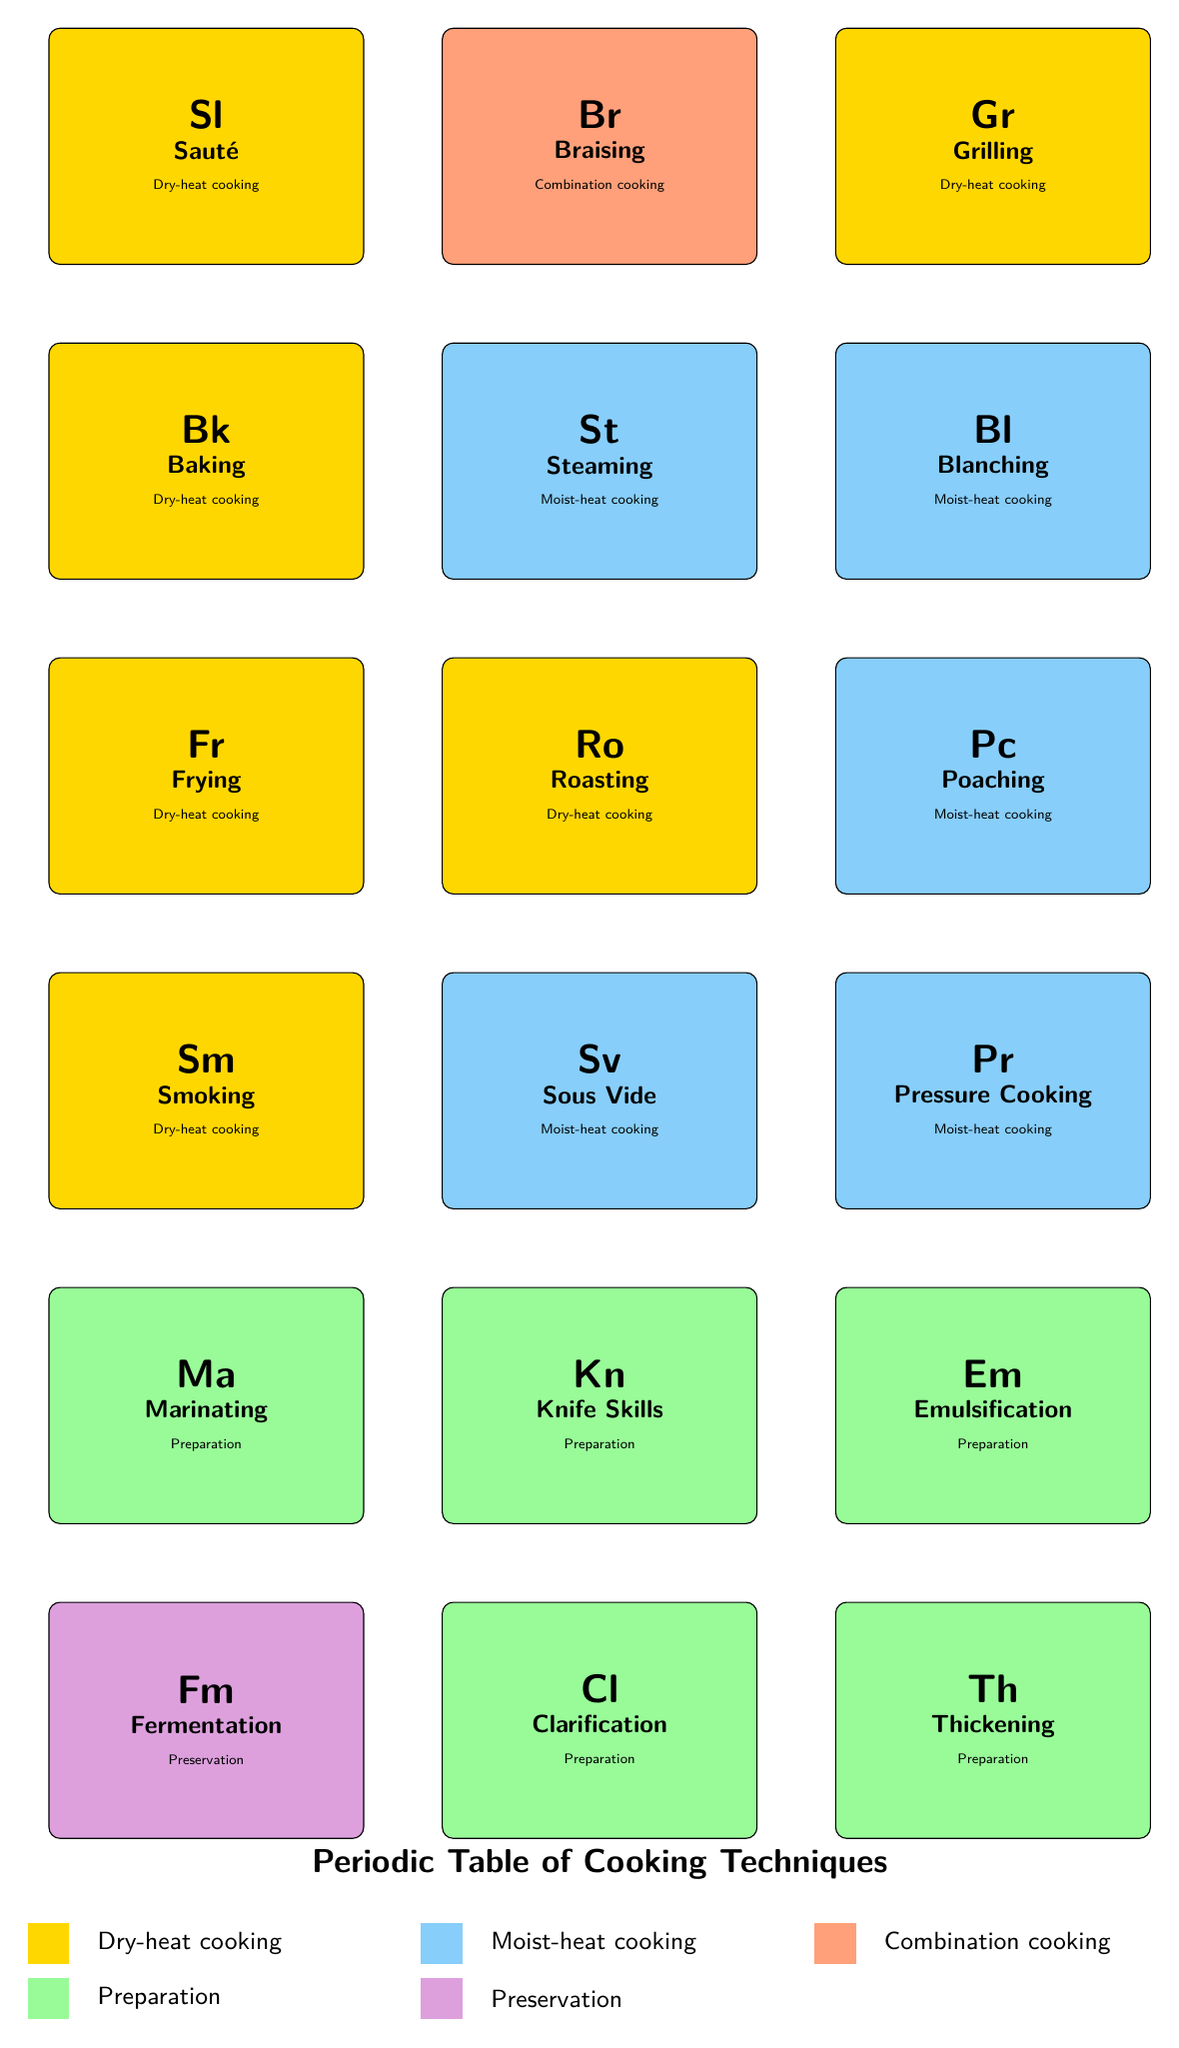What is the category of "Sauté"? Looking at the table, "Sauté" is listed under the "category" column, which shows it as "Dry-heat cooking."
Answer: Dry-heat cooking How many cooking techniques are classified under "Moist-heat cooking"? By counting the entries in the table under the "Moist-heat cooking" category, we find that there are 6 techniques: Steaming, Blanching, Poaching, Sous Vide, Pressure Cooking, and Emulsification.
Answer: 6 Is "Baking" considered a preparation technique? Checking the category for "Baking," it is listed under "Dry-heat cooking," not "Preparation." Therefore, this statement is false.
Answer: No Which technique involves cooking over direct heat? The table lists "Grilling" as the technique with the description "Cooking over direct heat," so it directly provides this information.
Answer: Grilling What is the franchise relevance of "Marinating"? Looking at the description related to "Marinating," it states, "Flavor enhancement technique for various classes," which indicates its importance in classes.
Answer: Flavor enhancement technique for various classes Which cooking technique is considered a time-saving method? The table shows that "Pressure Cooking" is noted as a time-saving technique for busy home cooks, making it the answer.
Answer: Pressure Cooking How many techniques belong to the "Preparation" category? By filtering through the table for the category “Preparation,” we find 6 techniques: Marinating, Knife Skills, Emulsification, Clarification, Thickening, and Fermentation.
Answer: 6 What is the unique characteristic of "Smoking" as a cooking technique? The unique characteristic of "Smoking" is noted in the description as "Flavoring and preserving with smoke," which distinguishes it from others.
Answer: Flavoring and preserving with smoke Which cooking technique has a focus on health in its franchise relevance? The table describes "Steaming" with a franchise relevance of "Healthy cooking method for wellness-focused classes," indicating its health benefits.
Answer: Steaming 